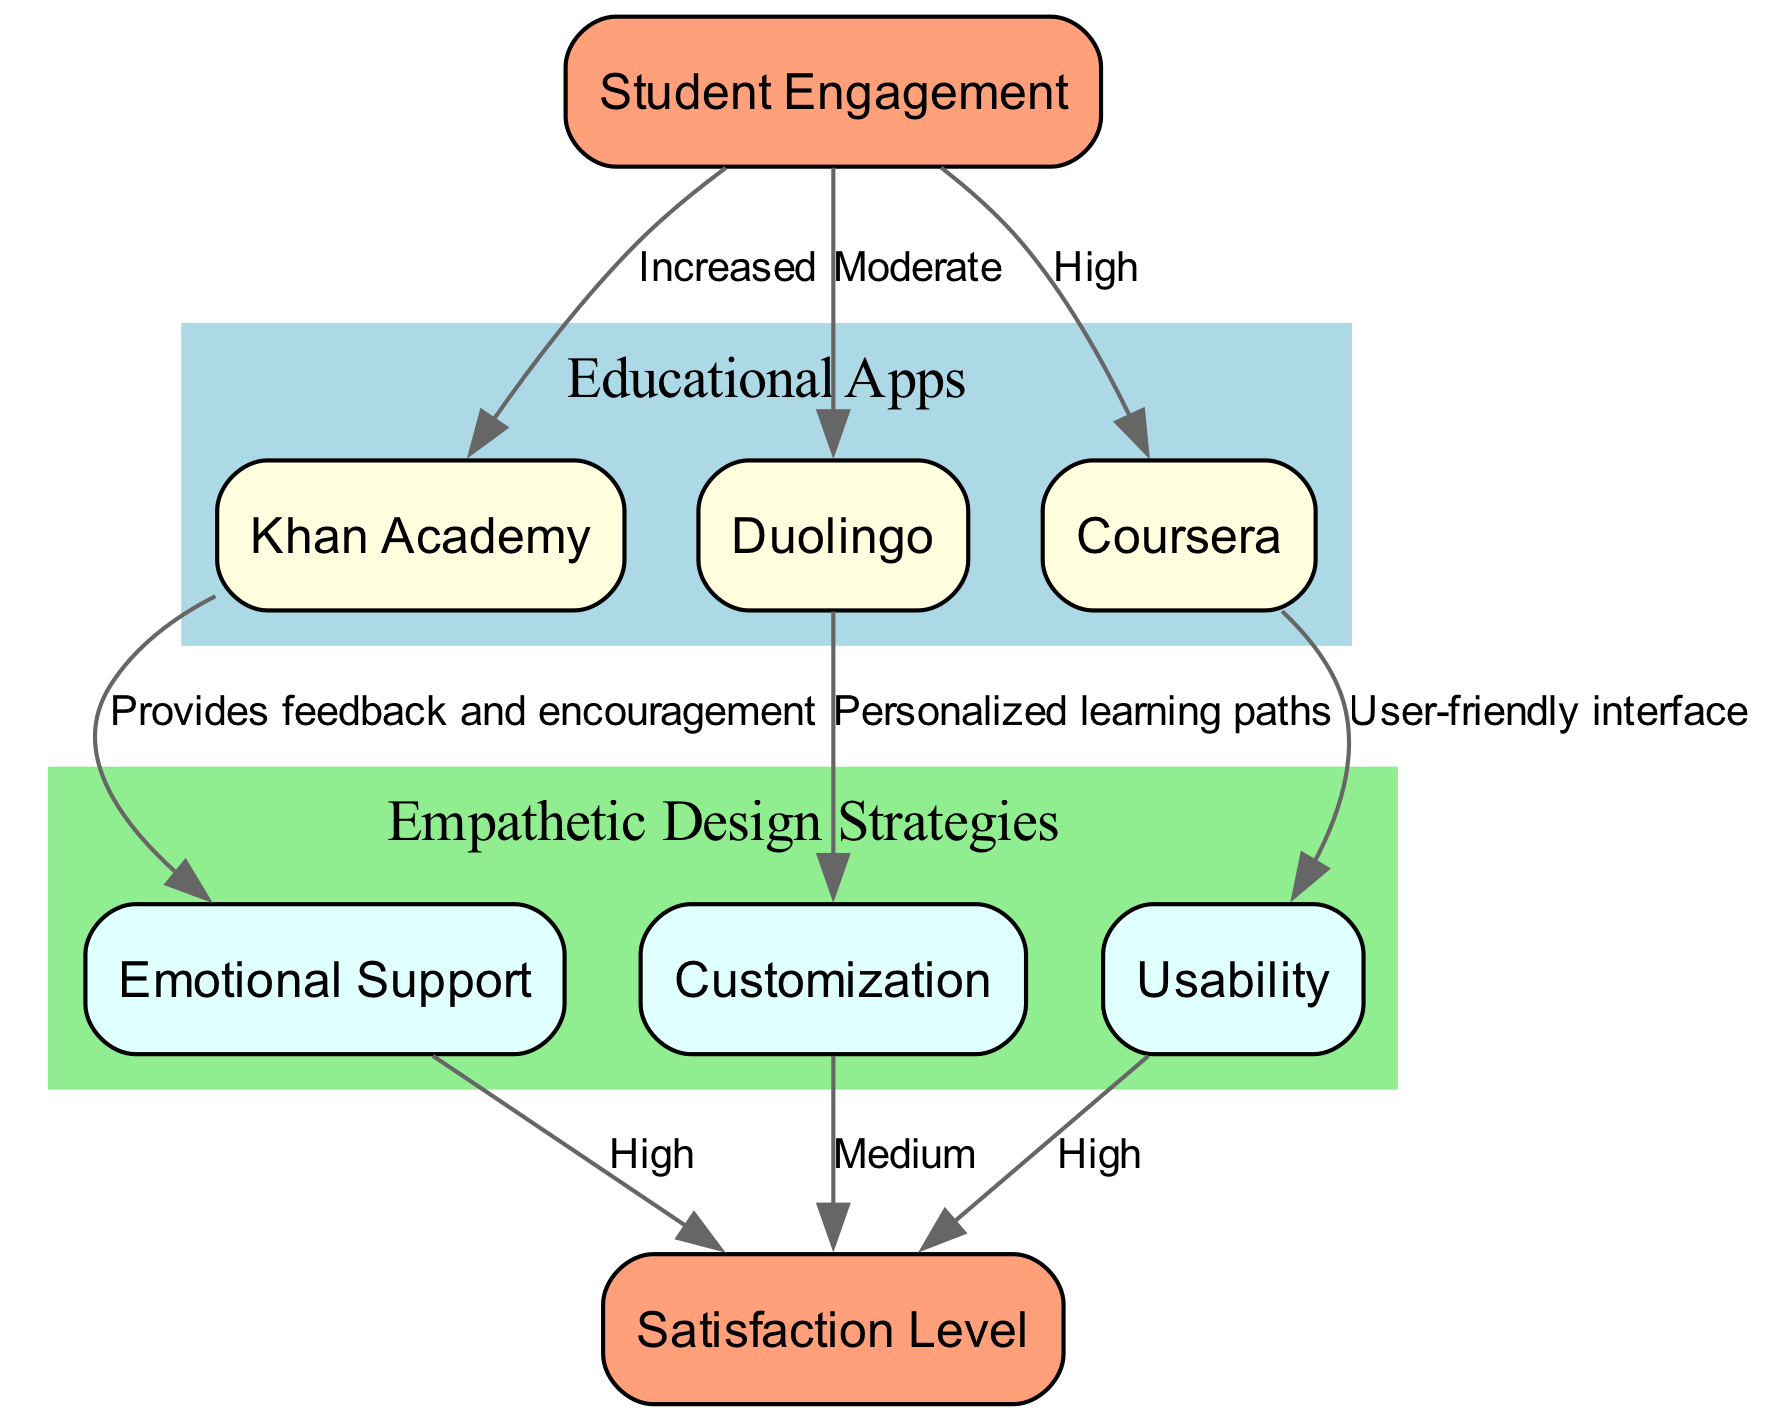What empathetic design strategy is used by Khan Academy? The diagram shows an edge from "khan_academy" to "emotional_support" labeled "Provides feedback and encouragement", indicating that Khan Academy employs emotional support as its empathetic design strategy.
Answer: Emotional Support Which educational app is linked to customization? Looking at the diagram, "duolingo" has an edge pointing to "customization" with the label "Personalized learning paths", showing that Duolingo implements customization in its design.
Answer: Duolingo How many edges are present in the diagram? By counting the connections between different nodes, we find there are a total of 8 edges represented in the diagram that illustrate the relationships between apps and design strategies.
Answer: 8 What is the satisfaction level linked to usability? The diagram has an edge from "usability" to "satisfaction_level" marked "High", which directly indicates the level of satisfaction associated with usability.
Answer: High What is the relationship between student engagement and Coursera? The diagram displays an edge from "student_engagement" to "coursera" labeled "High", signifying that Coursera is associated with high student engagement.
Answer: High Which design strategy has a medium satisfaction level? According to the diagram, "customization" has an edge leading to "satisfaction_level" labeled "Medium", indicating the associated satisfaction level with that strategy.
Answer: Medium Which educational app is characterized by a user-friendly interface? The edge from "coursera" to "usability" with the label "User-friendly interface" notes that Coursera is the app characterized by a user-friendly interface in the context of usability.
Answer: Coursera What empathetic design strategy contributes to both Khan Academy and Coursera? The diagram indicates that both "khan_academy" and "coursera" are linked to "satisfaction_level" via edges from "emotional_support" and "usability" respectively, which can lead to high user satisfaction. Therefore, the empathetic design strategies of emotional support and usability contribute to both.
Answer: Emotional Support; Usability What is the primary empathetic design strategy used by Duolingo for engagement? In the diagram, "student_engagement" points to "duolingo" with the label "Moderate", reflecting that Duolingo uses customization as the primary strategy contributing to its moderate student engagement.
Answer: Customization 